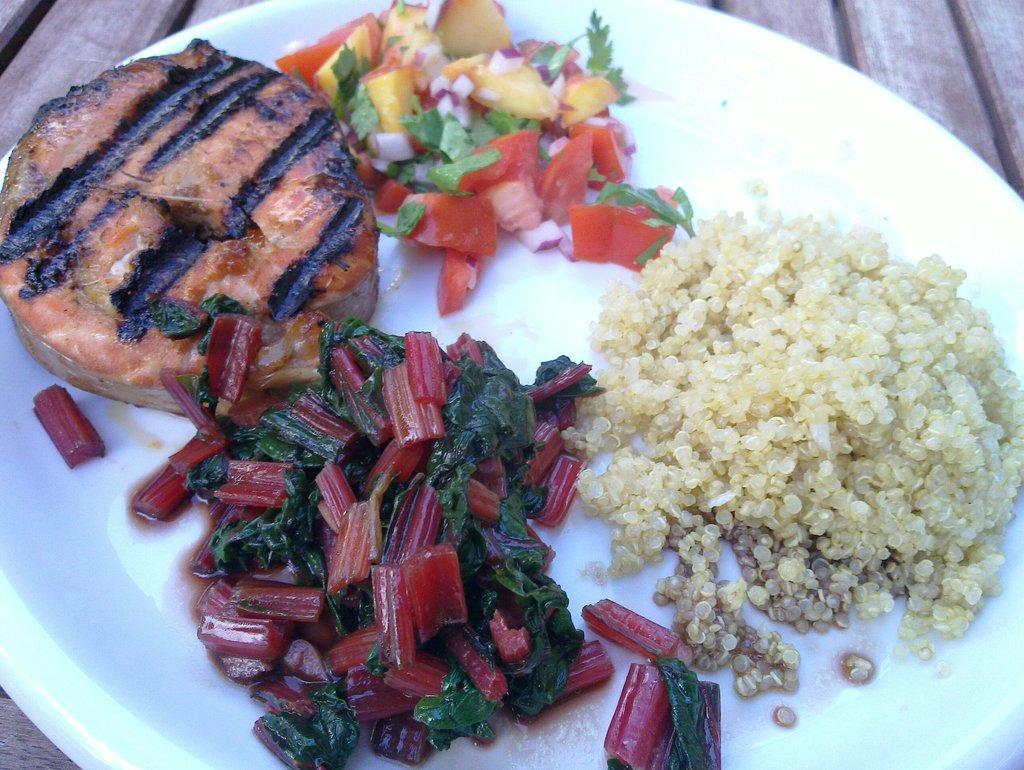What type of food can be seen in the image? There are cooked vegetables, a salad, and a grilled food item in the image. How are the food items arranged in the image? The items are served on a plate. Where is the plate with the food items located? The plate is kept on a table. What type of flower is present in the image? There is no flower present in the image; it features cooked vegetables, a salad, and a grilled food item served on a plate. Can you hear the voice of the person who prepared the food in the image? The image is a still photograph and does not contain any sound or voice, so it is not possible to hear the voice of the person who prepared the food. 